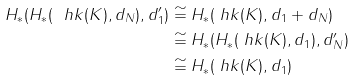Convert formula to latex. <formula><loc_0><loc_0><loc_500><loc_500>H _ { * } ( H _ { * } ( \ h k ( K ) , d _ { N } ) , d _ { 1 } ^ { \prime } ) & \cong H _ { * } ( \ h k ( K ) , d _ { 1 } + d _ { N } ) \\ & \cong H _ { * } ( H _ { * } ( \ h k ( K ) , d _ { 1 } ) , d _ { N } ^ { \prime } ) \\ & \cong H _ { * } ( \ h k ( K ) , d _ { 1 } )</formula> 